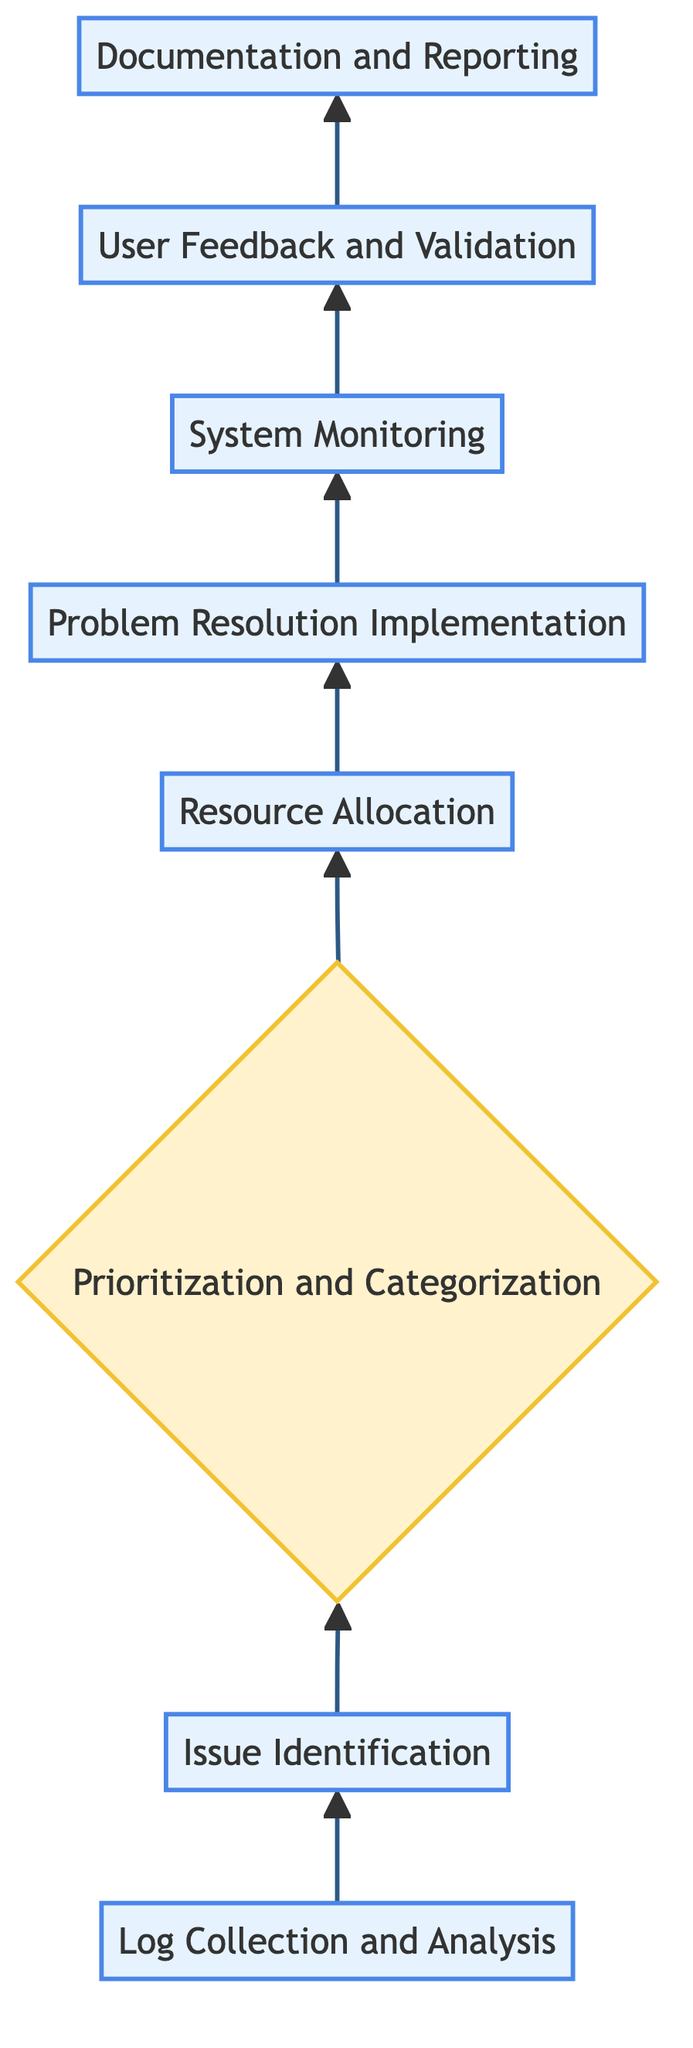What is the first process in the workflow? The first process in the workflow is "Log Collection and Analysis," as it is the starting point of the flow, indicated at the bottom of the diagram.
Answer: Log Collection and Analysis How many processes are there in the workflow? By counting the labeled nodes designated as processes, there are a total of six processes in the workflow: Log Collection and Analysis, Issue Identification, Resource Allocation, Problem Resolution Implementation, System Monitoring, and User Feedback and Validation.
Answer: Six processes What is the second step in the troubleshooting workflow? The second step in the troubleshooting workflow following "Log Collection and Analysis" is "Issue Identification," which is indicated by the arrow leading upward from the first step.
Answer: Issue Identification Which step follows the "Prioritization and Categorization"? The step that follows "Prioritization and Categorization" is "Resource Allocation," as shown in the flow sequence where there is a direct arrow from the decision node to the resource allocation process.
Answer: Resource Allocation Does "User Feedback and Validation" precede "Documentation and Reporting"? Yes, "User Feedback and Validation" does precede "Documentation and Reporting," as there is an upward flow from the user feedback process to the documentation process in the diagram.
Answer: Yes What type of node is "Prioritization and Categorization"? "Prioritization and Categorization" is classified as a decision node, which is visually different from processes and provides a branching point in the workflow based on conditions.
Answer: Decision How many total nodes are in the diagram? The total number of nodes, including both processes and the decision node, is eight, consisting of six processes and one decision node.
Answer: Eight nodes What action comes immediately after "Problem Resolution Implementation"? The action that comes immediately after "Problem Resolution Implementation" is "System Monitoring," as indicated by the direct vertical arrow in the flow.
Answer: System Monitoring 